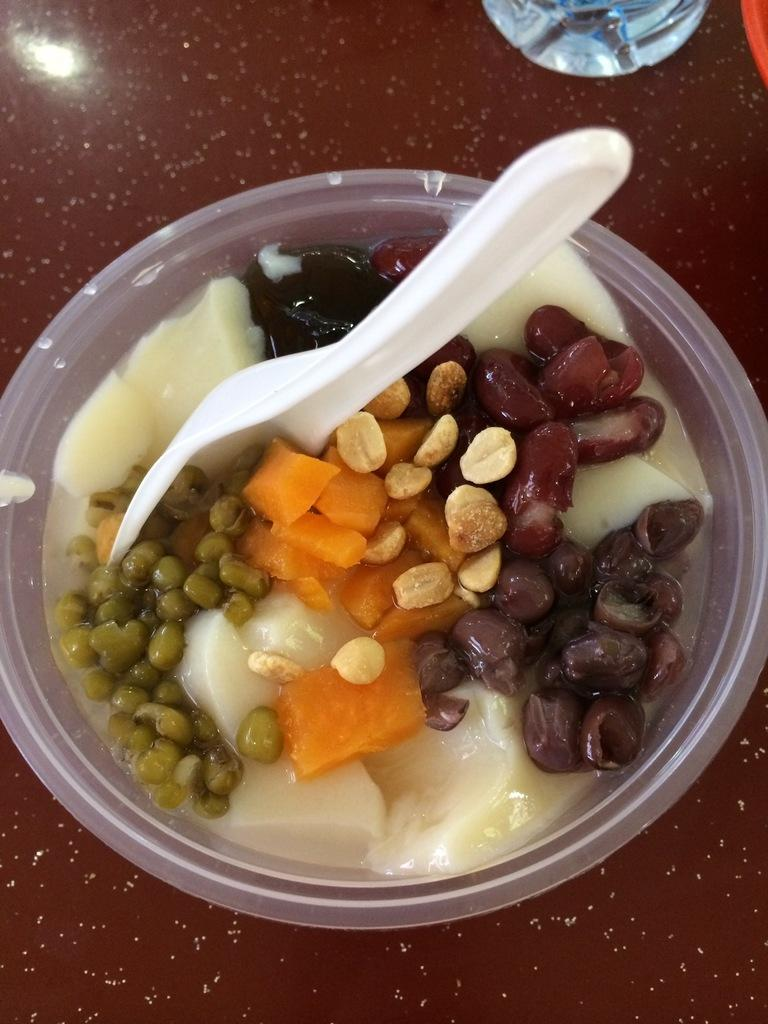What is the main object on the surface in the image? There is a bowl on the surface in the image. What is inside the bowl? The bowl contains a food item. Is there any utensil in the bowl? Yes, there is a spoon in the bowl. How many basketballs can be seen on the surface in the image? There are no basketballs present in the image. Are there any chairs visible on the surface in the image? There is no mention of chairs in the provided facts, and therefore we cannot determine if any are present in the image. 